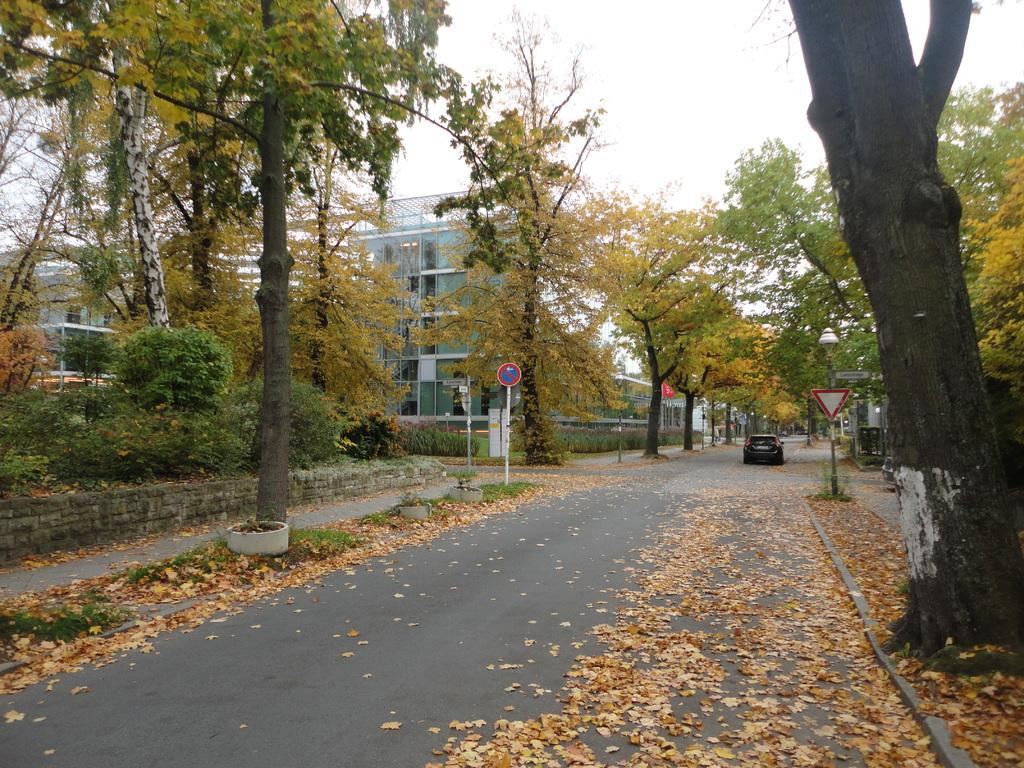What type of natural elements can be seen in the image? There are dried leaves and trees in the image. What man-made structures are present in the image? There are vehicles, buildings, and sign boards attached to poles in the image. What is the condition of the sky in the background of the image? The sky is visible in the background of the image. Can you tell me how many clams are present in the image? There are no clams present in the image. What type of skate is being used by the person in the image? There is no person or skate visible in the image. 